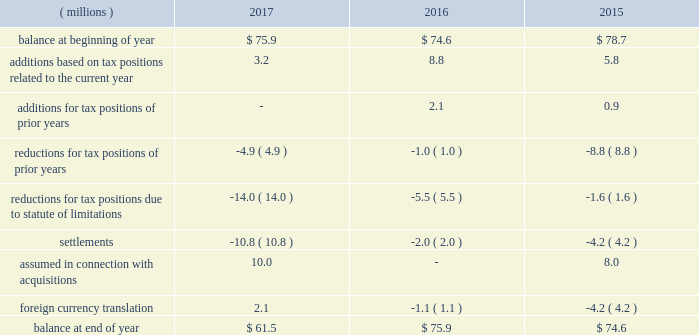The company 2019s 2017 reported tax rate includes $ 160.9 million of net tax benefits associated with the tax act , $ 6.2 million of net tax benefits on special gains and charges , and net tax benefits of $ 25.3 million associated with discrete tax items .
In connection with the company 2019s initial analysis of the impact of the tax act , as noted above , a provisional net discrete tax benefit of $ 160.9 million was recorded in the period ended december 31 , 2017 , which includes $ 321.0 million tax benefit for recording deferred tax assets and liabilities at the u.s .
Enacted tax rate , and a net expense for the one-time transition tax of $ 160.1 million .
While the company was able to make an estimate of the impact of the reduction in the u.s .
Rate on deferred tax assets and liabilities and the one-time transition tax , it may be affected by other analyses related to the tax act , as indicated above .
Special ( gains ) and charges represent the tax impact of special ( gains ) and charges , as well as additional tax benefits utilized in anticipation of u.s .
Tax reform of $ 7.8 million .
During 2017 , the company recorded a discrete tax benefit of $ 39.7 million related to excess tax benefits , resulting from the adoption of accounting changes regarding the treatment of tax benefits on share-based compensation .
The extent of excess tax benefits is subject to variation in stock price and stock option exercises .
In addition , the company recorded net discrete expenses of $ 14.4 million related to recognizing adjustments from filing the 2016 u.s .
Federal income tax return and international adjustments due to changes in estimates , partially offset by the release of reserves for uncertain tax positions due to the expiration of statute of limitations in state tax matters .
During 2016 , the company recognized net expense related to discrete tax items of $ 3.9 million .
The net expenses were driven primarily by recognizing adjustments from filing the company 2019s 2015 u.s .
Federal income tax return , partially offset by settlement of international tax matters and remeasurement of certain deferred tax assets and liabilities resulting from the application of updated tax rates in international jurisdictions .
Net expense was also impacted by adjustments to deferred tax asset and liability positions and the release of reserves for uncertain tax positions due to the expiration of statute of limitations in non-u.s .
Jurisdictions .
During 2015 , the company recognized net benefits related to discrete tax items of $ 63.3 million .
The net benefits were driven primarily by the release of $ 20.6 million of valuation allowances , based on the realizability of foreign deferred tax assets and the ability to recognize a worthless stock deduction of $ 39.0 million for the tax basis in a wholly-owned domestic subsidiary .
A reconciliation of the beginning and ending amount of gross liability for unrecognized tax benefits is as follows: .
The total amount of unrecognized tax benefits , if recognized would have affected the effective tax rate by $ 47.1 million as of december 31 , 2017 , $ 57.5 million as of december 31 , 2016 and $ 59.2 million as of december 31 , 2015 .
The company recognizes interest and penalties related to unrecognized tax benefits in its provision for income taxes .
During 2017 , 2016 and 2015 the company released $ 0.9 million , $ 2.9 million and $ 1.4 million related to interest and penalties , respectively .
The company had $ 9.3 million , $ 10.2 million and $ 13.1 million of accrued interest , including minor amounts for penalties , at december 31 , 2017 , 2016 , and 2015 , respectively. .
What percentage of the ending balance in unrecognized tax benefits relates to unrecognized tax benefits that would have affected the effective tax rate as of december 31 , 2017? 
Computations: (47.1 / 61.5)
Answer: 0.76585. 